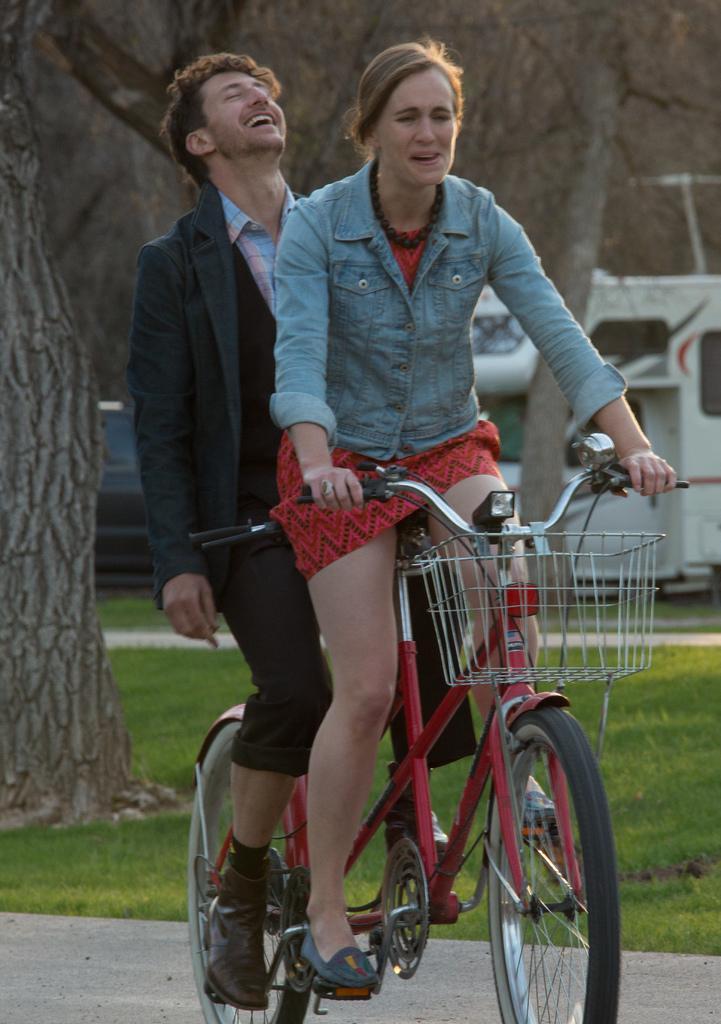Please provide a concise description of this image. The person wearing a blue jacket is a lady and the person who is wearing a black coat is a man, Both of them are riding a red bicycle, In background there are trees and their is also grass on the ground. 